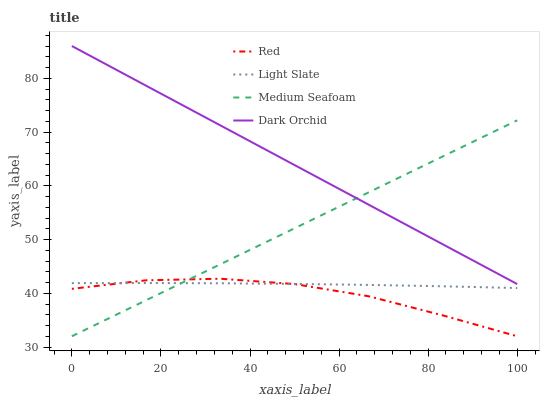Does Red have the minimum area under the curve?
Answer yes or no. Yes. Does Dark Orchid have the maximum area under the curve?
Answer yes or no. Yes. Does Medium Seafoam have the minimum area under the curve?
Answer yes or no. No. Does Medium Seafoam have the maximum area under the curve?
Answer yes or no. No. Is Medium Seafoam the smoothest?
Answer yes or no. Yes. Is Red the roughest?
Answer yes or no. Yes. Is Dark Orchid the smoothest?
Answer yes or no. No. Is Dark Orchid the roughest?
Answer yes or no. No. Does Medium Seafoam have the lowest value?
Answer yes or no. Yes. Does Dark Orchid have the lowest value?
Answer yes or no. No. Does Dark Orchid have the highest value?
Answer yes or no. Yes. Does Medium Seafoam have the highest value?
Answer yes or no. No. Is Light Slate less than Dark Orchid?
Answer yes or no. Yes. Is Dark Orchid greater than Light Slate?
Answer yes or no. Yes. Does Medium Seafoam intersect Dark Orchid?
Answer yes or no. Yes. Is Medium Seafoam less than Dark Orchid?
Answer yes or no. No. Is Medium Seafoam greater than Dark Orchid?
Answer yes or no. No. Does Light Slate intersect Dark Orchid?
Answer yes or no. No. 